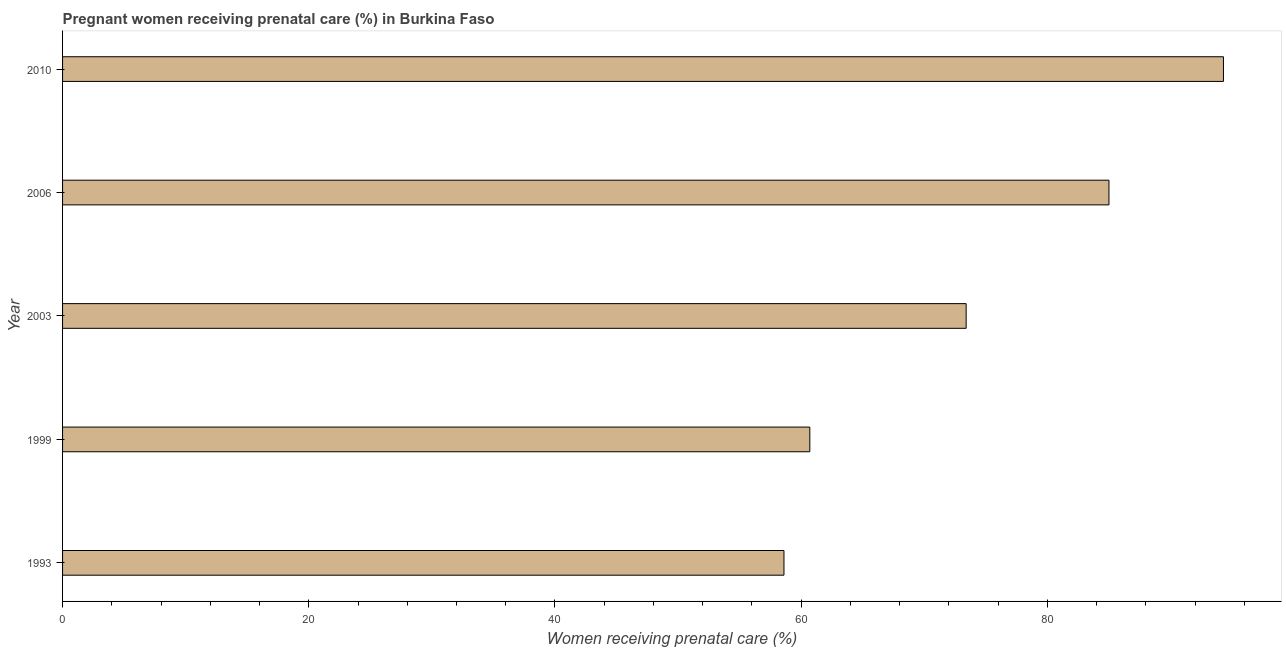Does the graph contain grids?
Your answer should be very brief. No. What is the title of the graph?
Provide a succinct answer. Pregnant women receiving prenatal care (%) in Burkina Faso. What is the label or title of the X-axis?
Offer a terse response. Women receiving prenatal care (%). What is the label or title of the Y-axis?
Keep it short and to the point. Year. What is the percentage of pregnant women receiving prenatal care in 1999?
Offer a very short reply. 60.7. Across all years, what is the maximum percentage of pregnant women receiving prenatal care?
Your answer should be very brief. 94.3. Across all years, what is the minimum percentage of pregnant women receiving prenatal care?
Offer a terse response. 58.6. In which year was the percentage of pregnant women receiving prenatal care maximum?
Make the answer very short. 2010. In which year was the percentage of pregnant women receiving prenatal care minimum?
Offer a terse response. 1993. What is the sum of the percentage of pregnant women receiving prenatal care?
Your response must be concise. 372. What is the difference between the percentage of pregnant women receiving prenatal care in 1999 and 2010?
Your response must be concise. -33.6. What is the average percentage of pregnant women receiving prenatal care per year?
Provide a short and direct response. 74.4. What is the median percentage of pregnant women receiving prenatal care?
Offer a very short reply. 73.4. Do a majority of the years between 1999 and 2010 (inclusive) have percentage of pregnant women receiving prenatal care greater than 20 %?
Offer a terse response. Yes. What is the ratio of the percentage of pregnant women receiving prenatal care in 1993 to that in 2003?
Provide a short and direct response. 0.8. Is the percentage of pregnant women receiving prenatal care in 1999 less than that in 2006?
Your answer should be compact. Yes. Is the sum of the percentage of pregnant women receiving prenatal care in 1993 and 2003 greater than the maximum percentage of pregnant women receiving prenatal care across all years?
Ensure brevity in your answer.  Yes. What is the difference between the highest and the lowest percentage of pregnant women receiving prenatal care?
Provide a short and direct response. 35.7. In how many years, is the percentage of pregnant women receiving prenatal care greater than the average percentage of pregnant women receiving prenatal care taken over all years?
Provide a short and direct response. 2. How many bars are there?
Your answer should be compact. 5. Are the values on the major ticks of X-axis written in scientific E-notation?
Your response must be concise. No. What is the Women receiving prenatal care (%) of 1993?
Keep it short and to the point. 58.6. What is the Women receiving prenatal care (%) in 1999?
Offer a terse response. 60.7. What is the Women receiving prenatal care (%) in 2003?
Your answer should be very brief. 73.4. What is the Women receiving prenatal care (%) of 2006?
Keep it short and to the point. 85. What is the Women receiving prenatal care (%) of 2010?
Provide a short and direct response. 94.3. What is the difference between the Women receiving prenatal care (%) in 1993 and 2003?
Offer a very short reply. -14.8. What is the difference between the Women receiving prenatal care (%) in 1993 and 2006?
Your answer should be very brief. -26.4. What is the difference between the Women receiving prenatal care (%) in 1993 and 2010?
Ensure brevity in your answer.  -35.7. What is the difference between the Women receiving prenatal care (%) in 1999 and 2003?
Ensure brevity in your answer.  -12.7. What is the difference between the Women receiving prenatal care (%) in 1999 and 2006?
Provide a succinct answer. -24.3. What is the difference between the Women receiving prenatal care (%) in 1999 and 2010?
Ensure brevity in your answer.  -33.6. What is the difference between the Women receiving prenatal care (%) in 2003 and 2006?
Offer a very short reply. -11.6. What is the difference between the Women receiving prenatal care (%) in 2003 and 2010?
Provide a short and direct response. -20.9. What is the difference between the Women receiving prenatal care (%) in 2006 and 2010?
Make the answer very short. -9.3. What is the ratio of the Women receiving prenatal care (%) in 1993 to that in 2003?
Provide a succinct answer. 0.8. What is the ratio of the Women receiving prenatal care (%) in 1993 to that in 2006?
Your answer should be compact. 0.69. What is the ratio of the Women receiving prenatal care (%) in 1993 to that in 2010?
Give a very brief answer. 0.62. What is the ratio of the Women receiving prenatal care (%) in 1999 to that in 2003?
Provide a short and direct response. 0.83. What is the ratio of the Women receiving prenatal care (%) in 1999 to that in 2006?
Make the answer very short. 0.71. What is the ratio of the Women receiving prenatal care (%) in 1999 to that in 2010?
Offer a very short reply. 0.64. What is the ratio of the Women receiving prenatal care (%) in 2003 to that in 2006?
Make the answer very short. 0.86. What is the ratio of the Women receiving prenatal care (%) in 2003 to that in 2010?
Give a very brief answer. 0.78. What is the ratio of the Women receiving prenatal care (%) in 2006 to that in 2010?
Give a very brief answer. 0.9. 